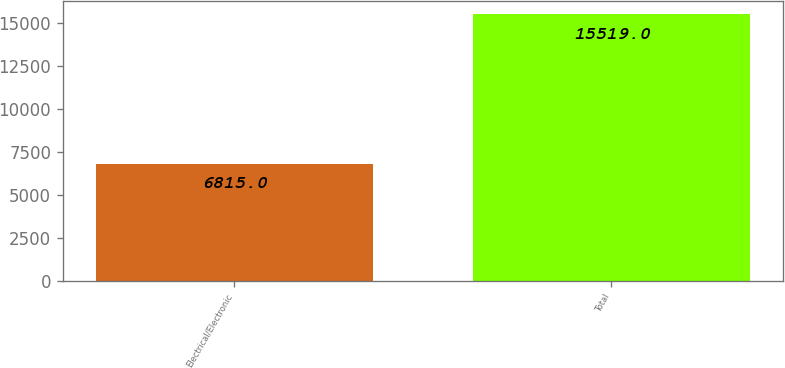Convert chart to OTSL. <chart><loc_0><loc_0><loc_500><loc_500><bar_chart><fcel>Electrical/Electronic<fcel>Total<nl><fcel>6815<fcel>15519<nl></chart> 